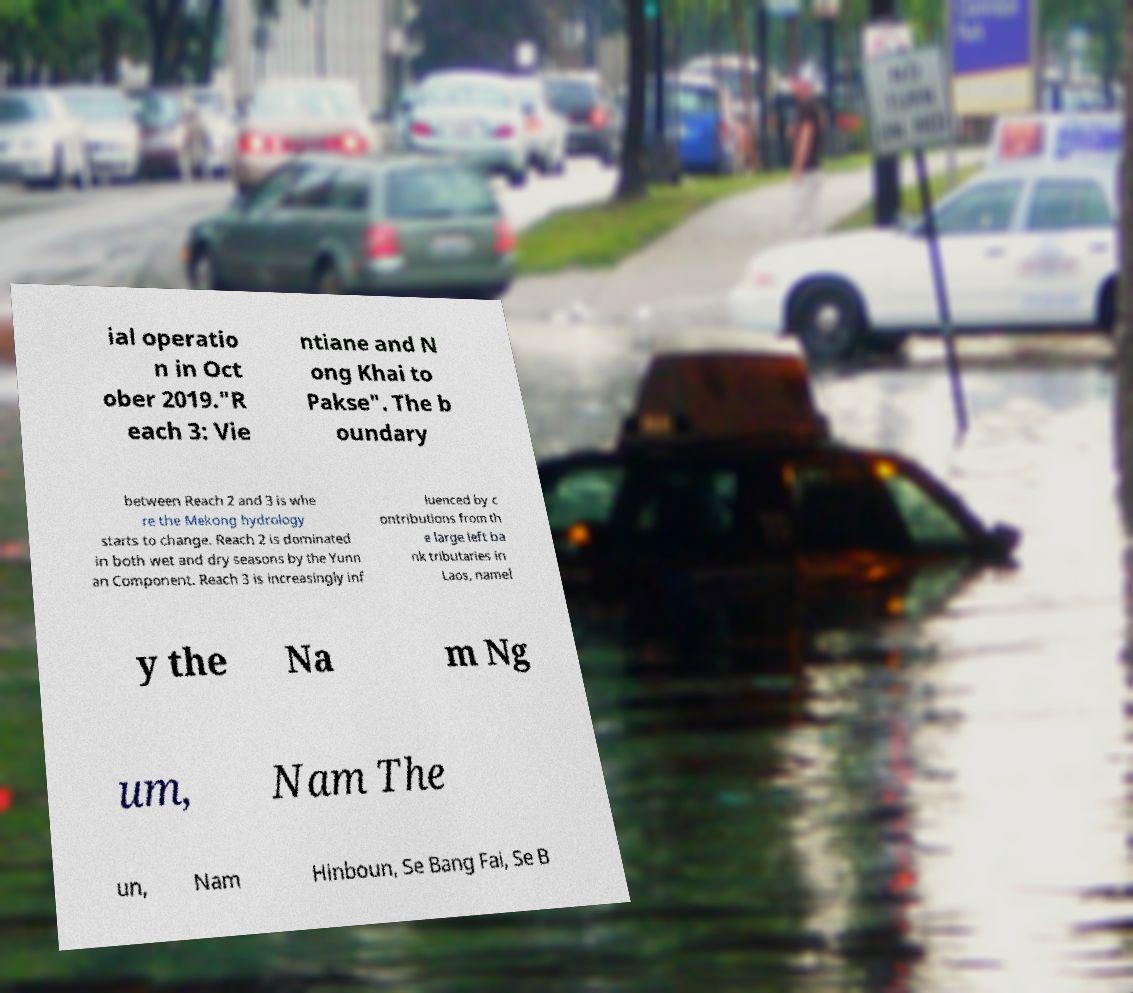Could you extract and type out the text from this image? ial operatio n in Oct ober 2019."R each 3: Vie ntiane and N ong Khai to Pakse". The b oundary between Reach 2 and 3 is whe re the Mekong hydrology starts to change. Reach 2 is dominated in both wet and dry seasons by the Yunn an Component. Reach 3 is increasingly inf luenced by c ontributions from th e large left ba nk tributaries in Laos, namel y the Na m Ng um, Nam The un, Nam Hinboun, Se Bang Fai, Se B 